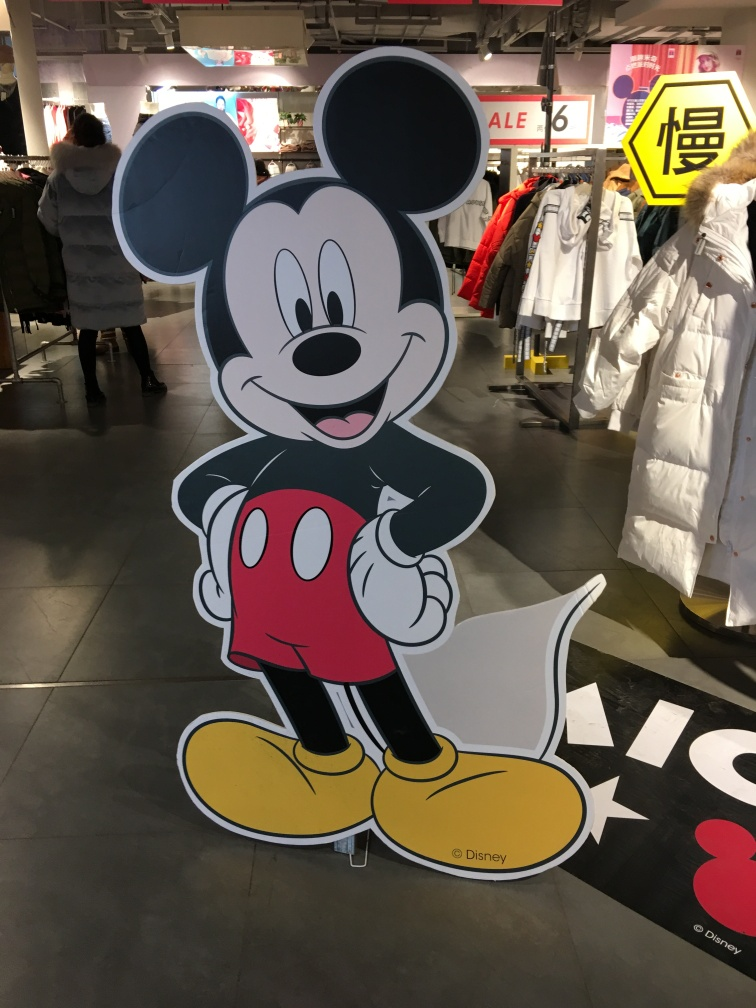What kind of setting is this character placed in, and does it enhance its visibility? The character is placed in a retail environment, likely for promotional purposes. Its placement against a relatively plain background with ample space ensures high visibility and draws attention to it effectively. 